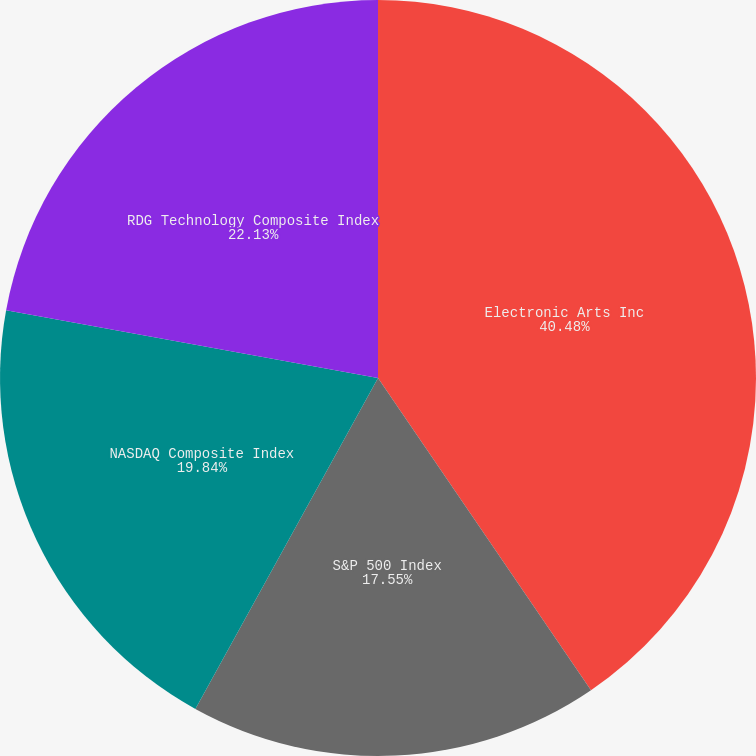Convert chart. <chart><loc_0><loc_0><loc_500><loc_500><pie_chart><fcel>Electronic Arts Inc<fcel>S&P 500 Index<fcel>NASDAQ Composite Index<fcel>RDG Technology Composite Index<nl><fcel>40.47%<fcel>17.55%<fcel>19.84%<fcel>22.13%<nl></chart> 